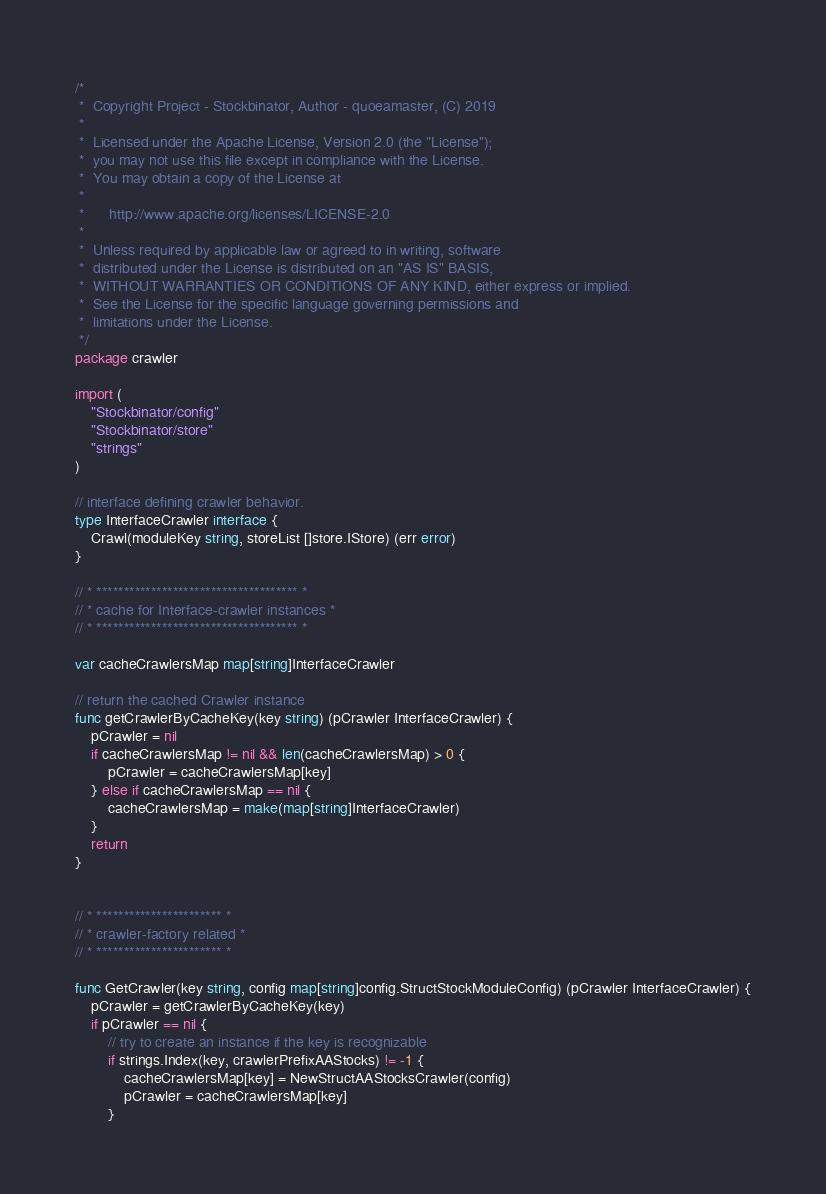Convert code to text. <code><loc_0><loc_0><loc_500><loc_500><_Go_>/*
 *  Copyright Project - Stockbinator, Author - quoeamaster, (C) 2019
 *
 *  Licensed under the Apache License, Version 2.0 (the "License");
 *  you may not use this file except in compliance with the License.
 *  You may obtain a copy of the License at
 *
 *      http://www.apache.org/licenses/LICENSE-2.0
 *
 *  Unless required by applicable law or agreed to in writing, software
 *  distributed under the License is distributed on an "AS IS" BASIS,
 *  WITHOUT WARRANTIES OR CONDITIONS OF ANY KIND, either express or implied.
 *  See the License for the specific language governing permissions and
 *  limitations under the License.
 */
package crawler

import (
	"Stockbinator/config"
	"Stockbinator/store"
	"strings"
)

// interface defining crawler behavior.
type InterfaceCrawler interface {
	Crawl(moduleKey string, storeList []store.IStore) (err error)
}

// * ************************************* *
// * cache for Interface-crawler instances *
// * ************************************* *

var cacheCrawlersMap map[string]InterfaceCrawler

// return the cached Crawler instance
func getCrawlerByCacheKey(key string) (pCrawler InterfaceCrawler) {
	pCrawler = nil
	if cacheCrawlersMap != nil && len(cacheCrawlersMap) > 0 {
		pCrawler = cacheCrawlersMap[key]
	} else if cacheCrawlersMap == nil {
		cacheCrawlersMap = make(map[string]InterfaceCrawler)
	}
	return
}


// * *********************** *
// * crawler-factory related *
// * *********************** *

func GetCrawler(key string, config map[string]config.StructStockModuleConfig) (pCrawler InterfaceCrawler) {
	pCrawler = getCrawlerByCacheKey(key)
	if pCrawler == nil {
		// try to create an instance if the key is recognizable
		if strings.Index(key, crawlerPrefixAAStocks) != -1 {
			cacheCrawlersMap[key] = NewStructAAStocksCrawler(config)
			pCrawler = cacheCrawlersMap[key]
		}</code> 